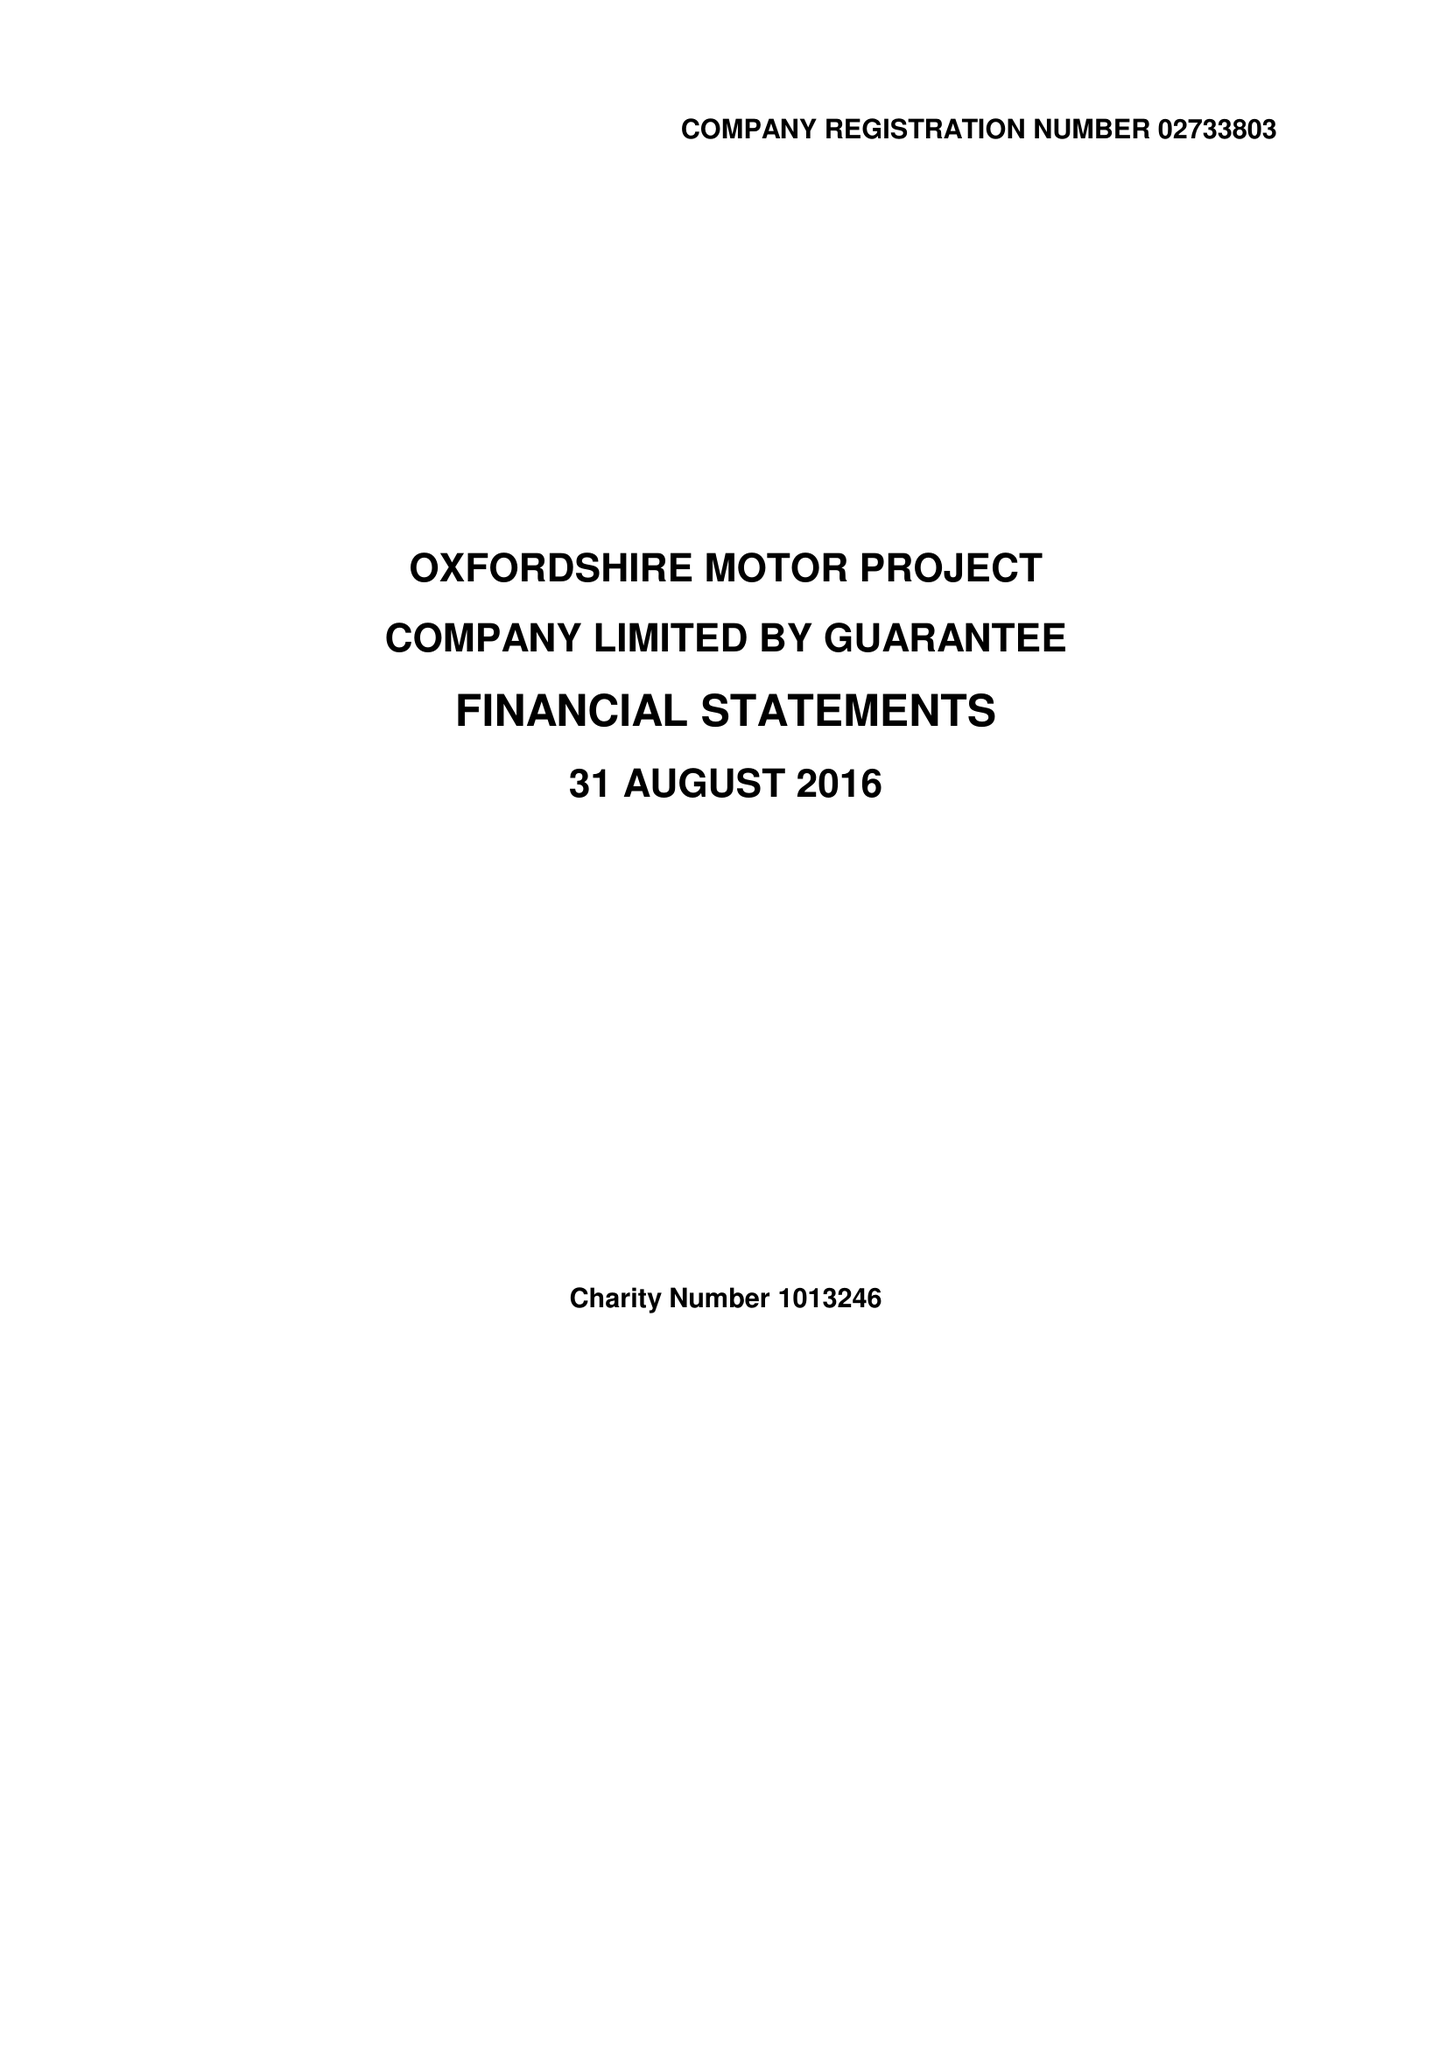What is the value for the address__postcode?
Answer the question using a single word or phrase. OX2 8JR 